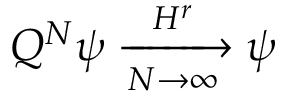<formula> <loc_0><loc_0><loc_500><loc_500>Q ^ { N } \psi \xrightarrow [ N \rightarrow \infty ] { H ^ { r } } \psi</formula> 